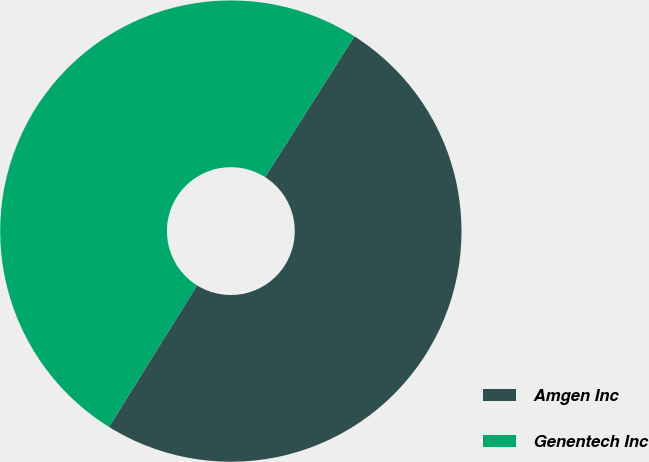Convert chart to OTSL. <chart><loc_0><loc_0><loc_500><loc_500><pie_chart><fcel>Amgen Inc<fcel>Genentech Inc<nl><fcel>49.86%<fcel>50.14%<nl></chart> 